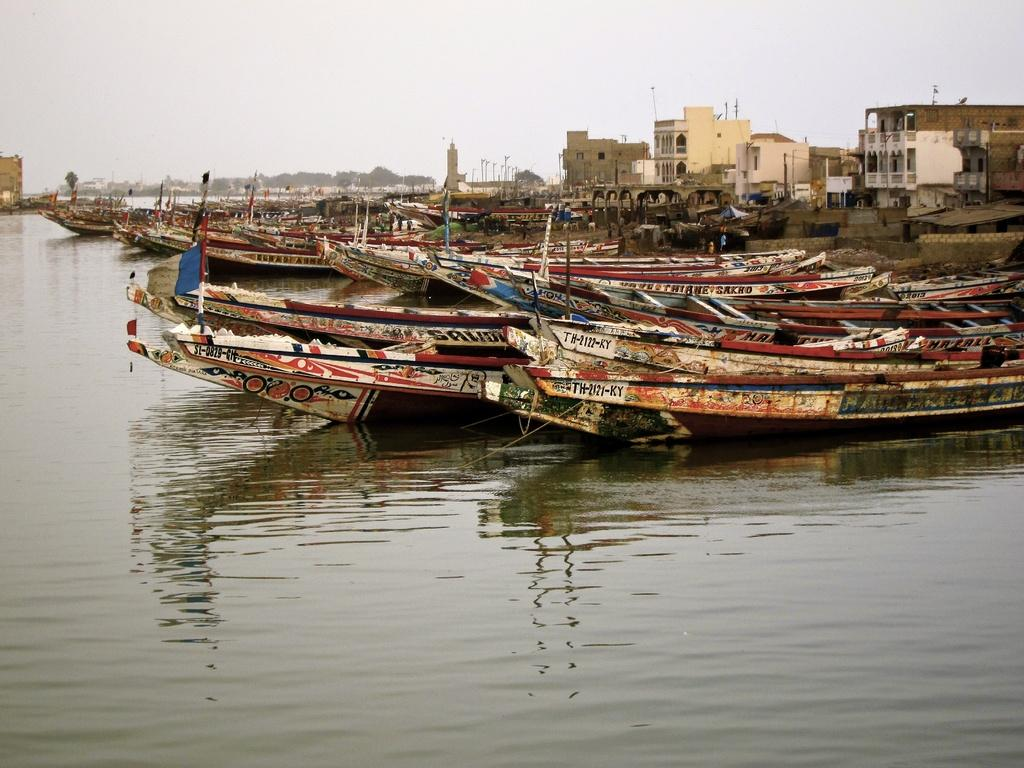What is in the water in the image? There are boats in the water in the image. What can be seen behind the boats? There are buildings and trees visible behind the boats. Are there any giants visible in the image? No, there are no giants present in the image. 